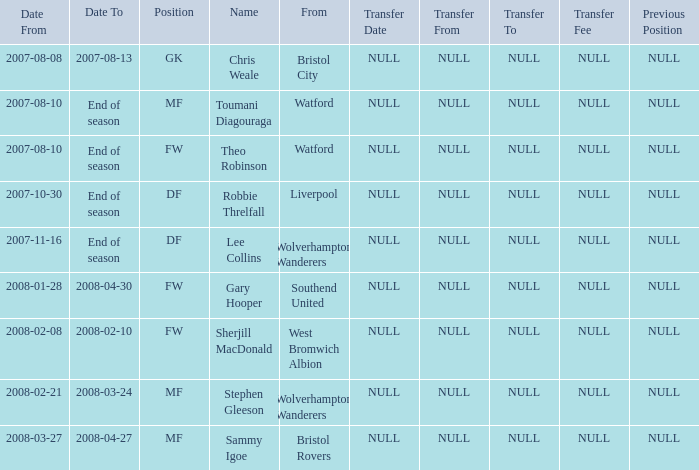When did toumani diagouraga, an mf player, commence? 2007-08-10. 